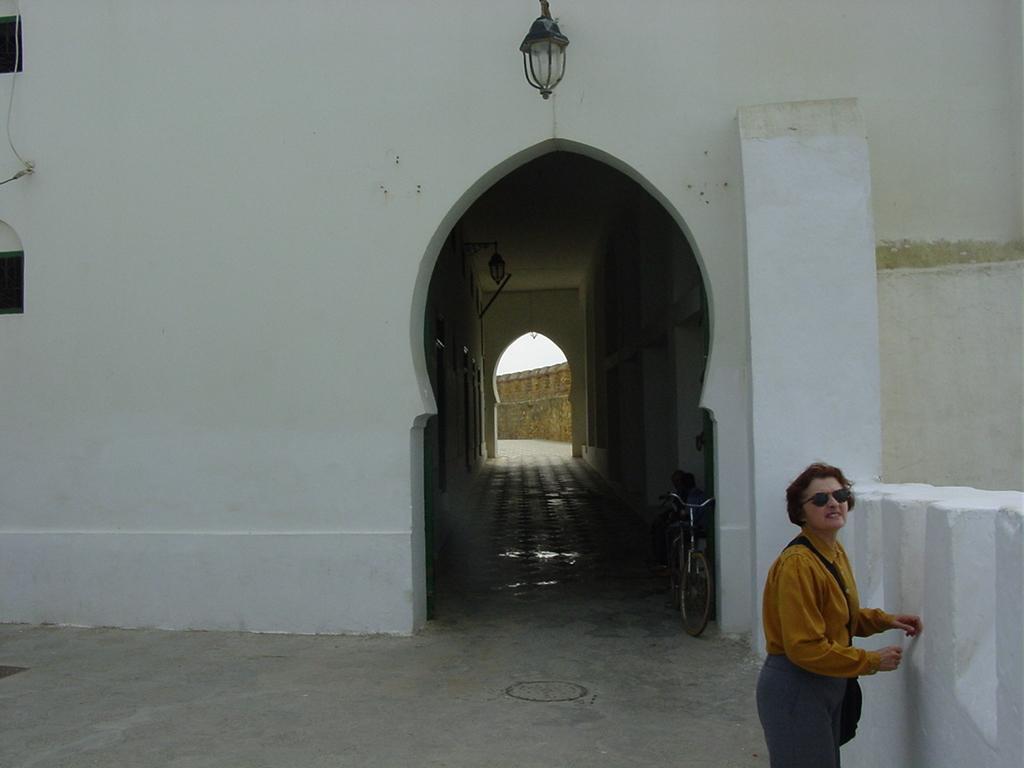In one or two sentences, can you explain what this image depicts? In this image I can see a white color building,bicycle and woman is standing. The woman is wearing a bag. Top I can see a light. 